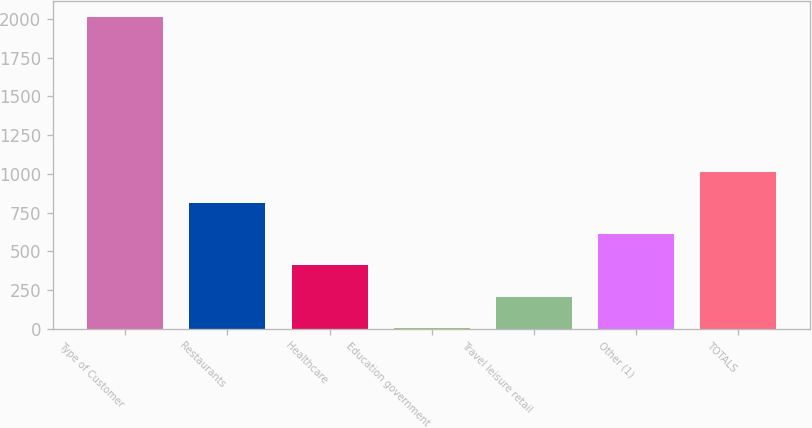Convert chart. <chart><loc_0><loc_0><loc_500><loc_500><bar_chart><fcel>Type of Customer<fcel>Restaurants<fcel>Healthcare<fcel>Education government<fcel>Travel leisure retail<fcel>Other (1)<fcel>TOTALS<nl><fcel>2013<fcel>810<fcel>409<fcel>8<fcel>208.5<fcel>609.5<fcel>1010.5<nl></chart> 